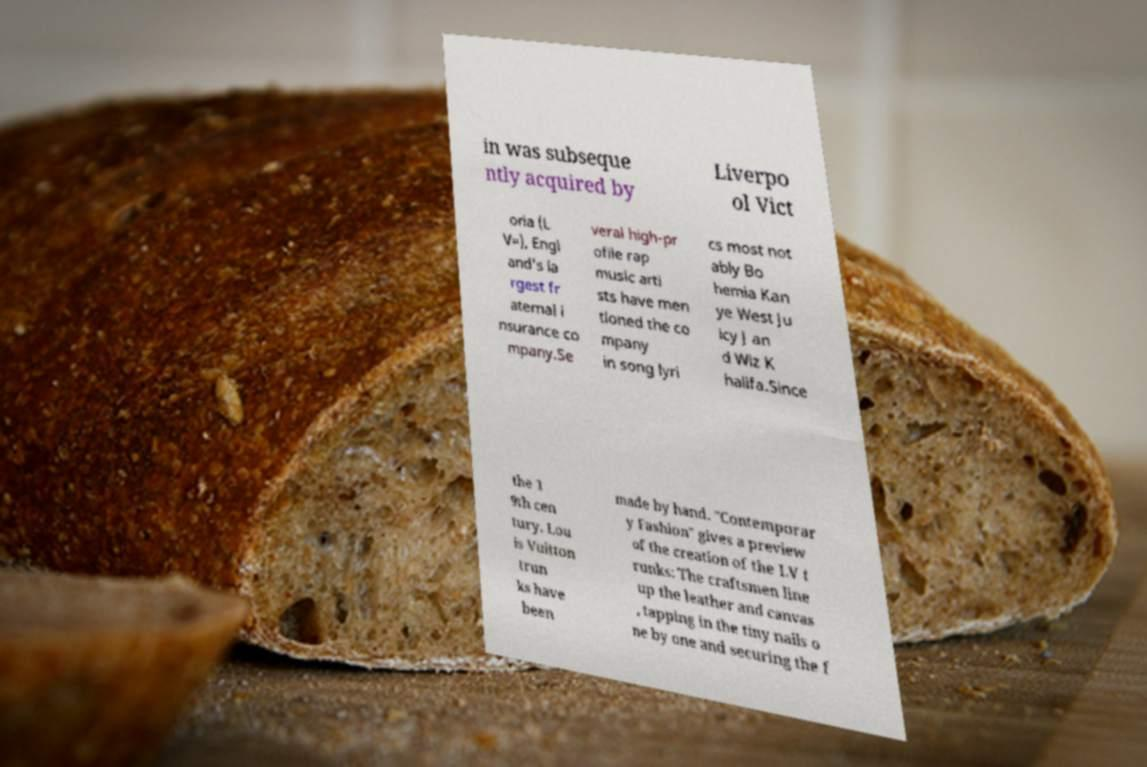Could you extract and type out the text from this image? in was subseque ntly acquired by Liverpo ol Vict oria (L V=), Engl and's la rgest fr aternal i nsurance co mpany.Se veral high-pr ofile rap music arti sts have men tioned the co mpany in song lyri cs most not ably Bo hemia Kan ye West Ju icy J an d Wiz K halifa.Since the 1 9th cen tury, Lou is Vuitton trun ks have been made by hand. "Contemporar y Fashion" gives a preview of the creation of the LV t runks: The craftsmen line up the leather and canvas , tapping in the tiny nails o ne by one and securing the f 